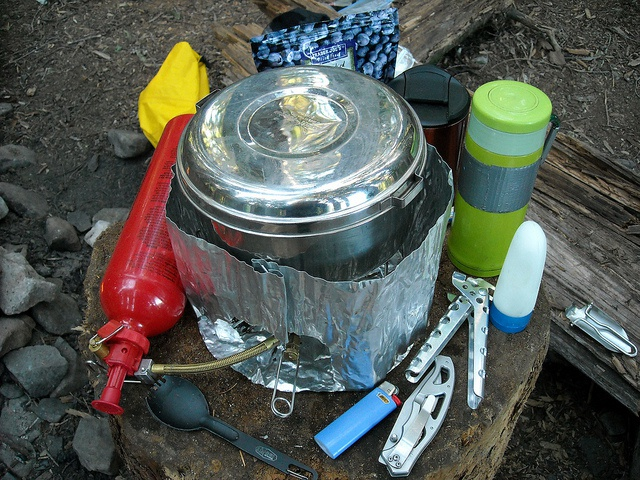Describe the objects in this image and their specific colors. I can see bottle in black, olive, lightgreen, turquoise, and teal tones, bottle in black, brown, and maroon tones, spoon in black, blue, darkblue, and purple tones, and knife in black, lightblue, and darkgray tones in this image. 